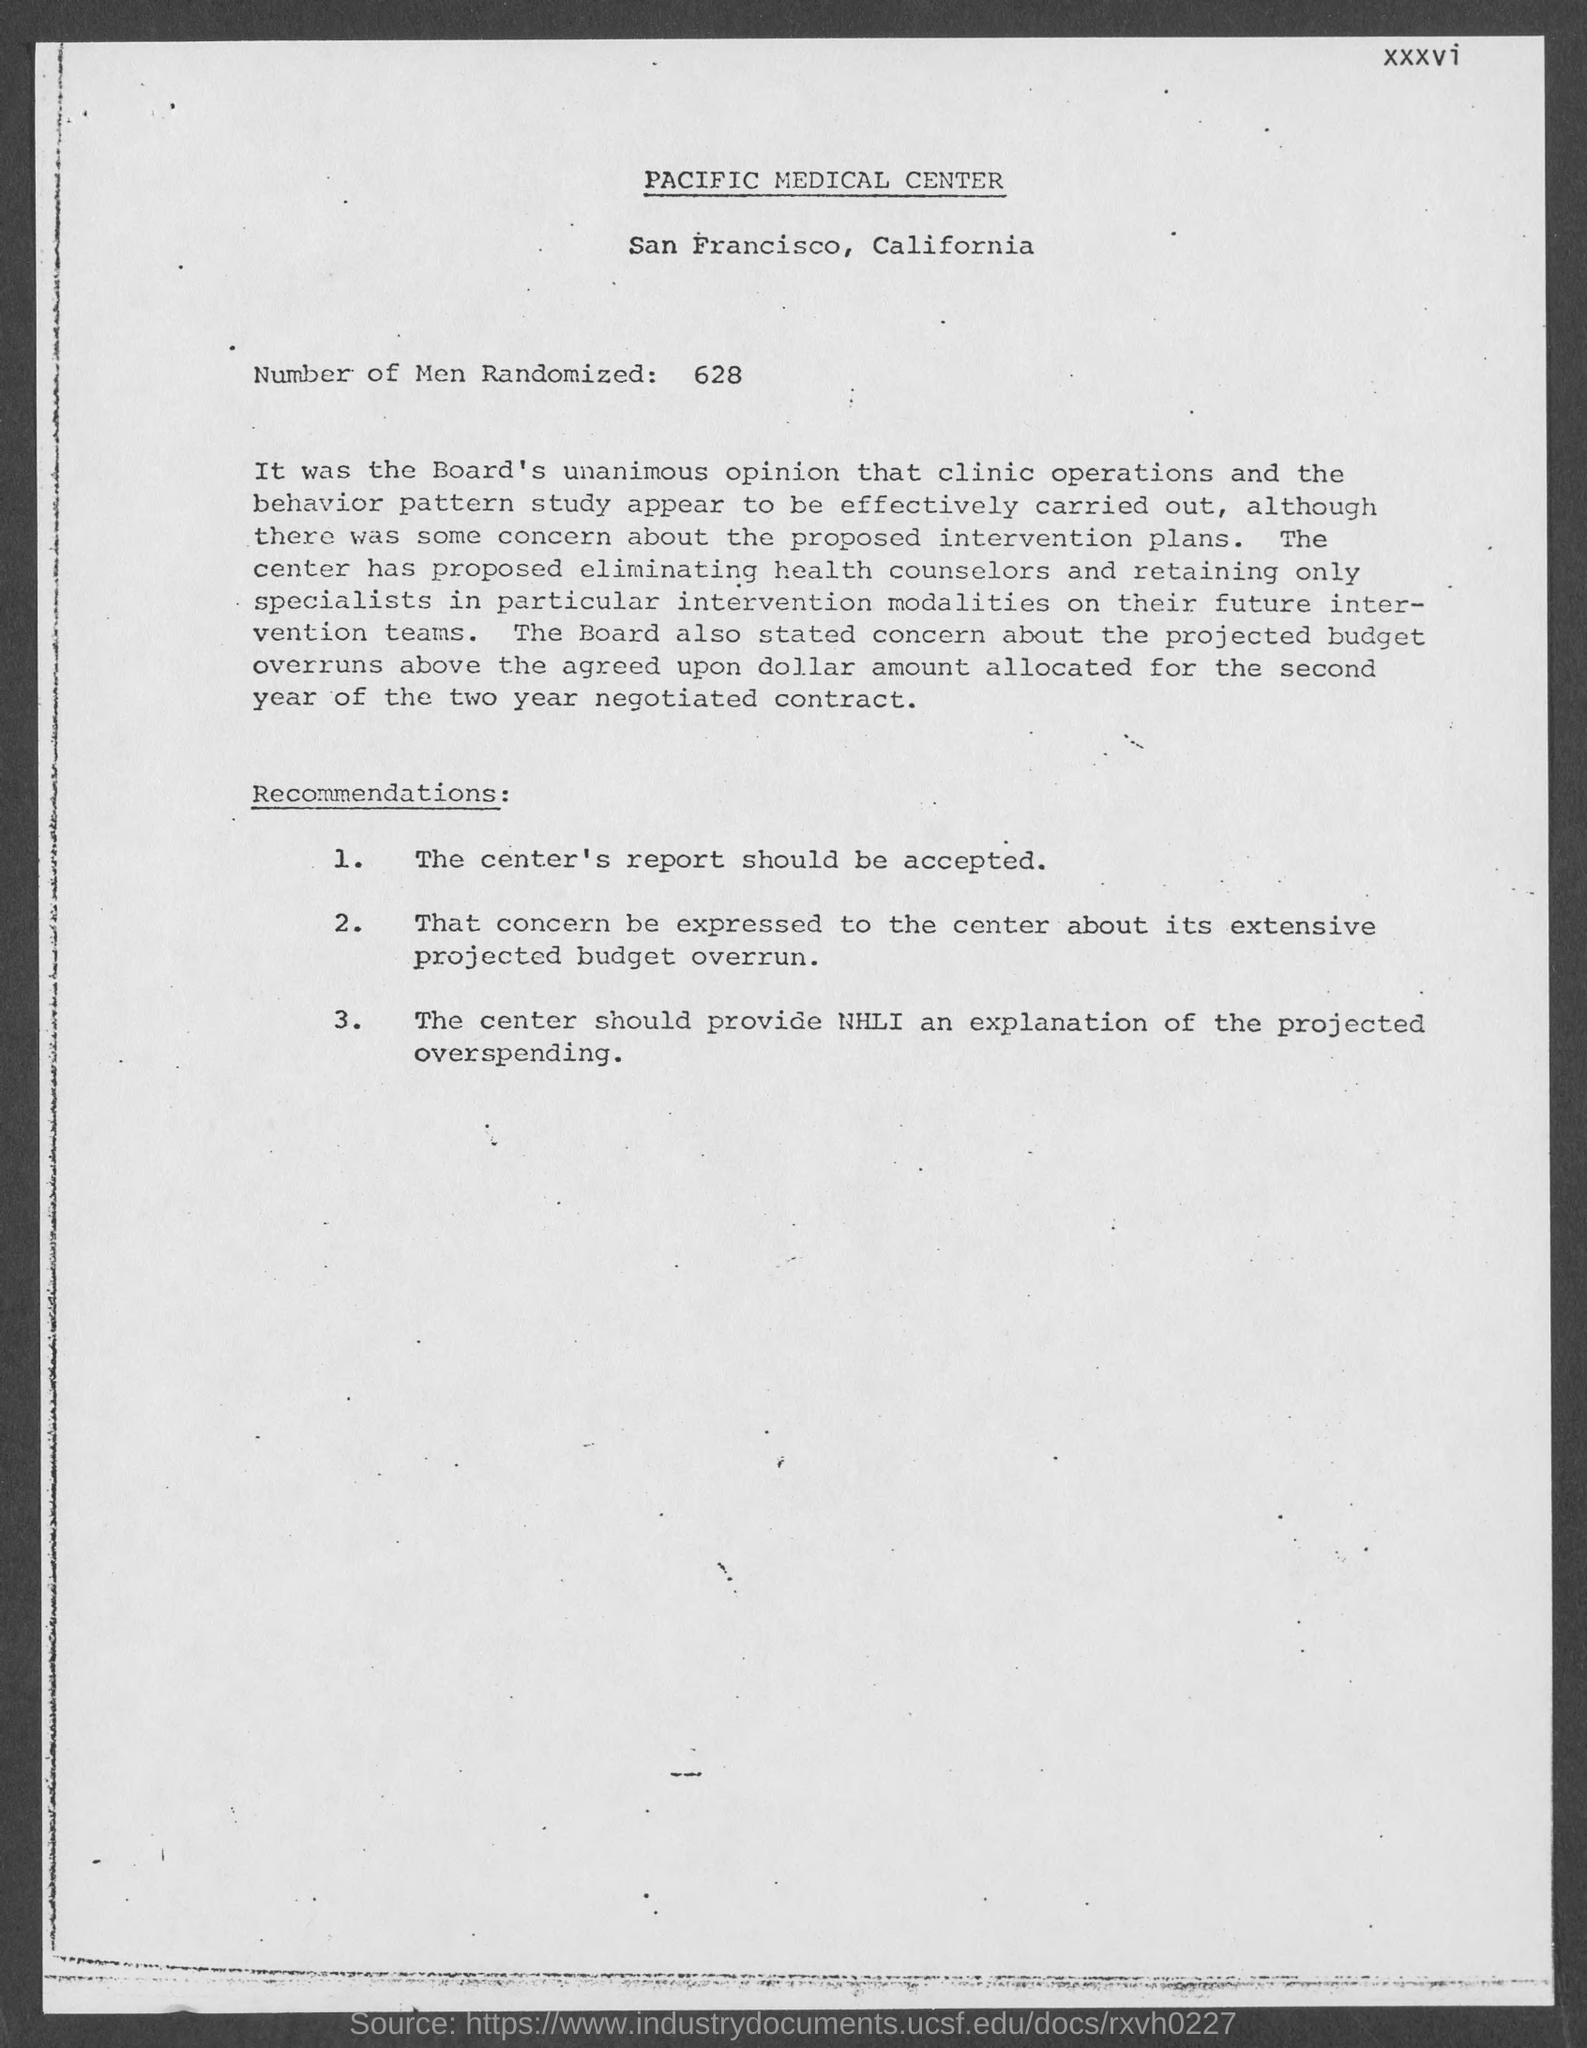How many number of men are randomized ?
Make the answer very short. 628. 